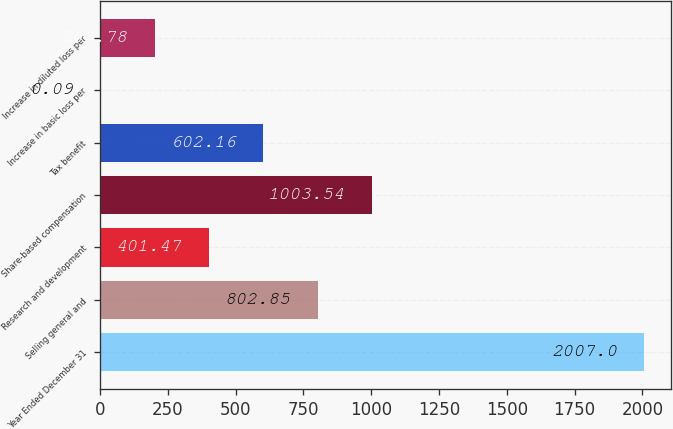<chart> <loc_0><loc_0><loc_500><loc_500><bar_chart><fcel>Year Ended December 31<fcel>Selling general and<fcel>Research and development<fcel>Share-based compensation<fcel>Tax benefit<fcel>Increase in basic loss per<fcel>Increase in diluted loss per<nl><fcel>2007<fcel>802.85<fcel>401.47<fcel>1003.54<fcel>602.16<fcel>0.09<fcel>200.78<nl></chart> 